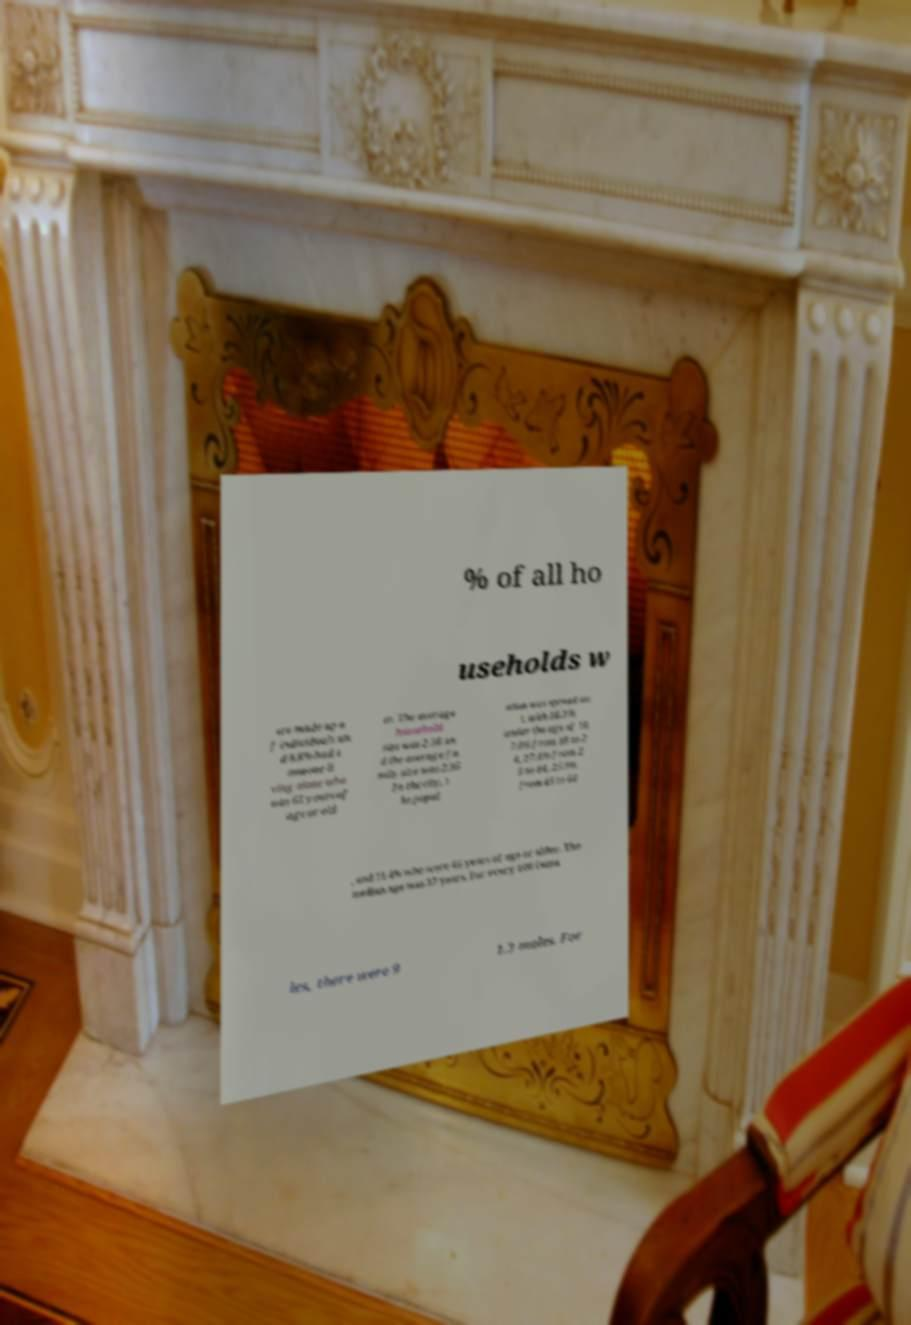Could you assist in decoding the text presented in this image and type it out clearly? % of all ho useholds w ere made up o f individuals an d 8.8% had s omeone li ving alone who was 65 years of age or old er. The average household size was 2.56 an d the average fa mily size was 2.95 .In the city, t he popul ation was spread ou t, with 28.3% under the age of 18, 7.0% from 18 to 2 4, 27.4% from 2 5 to 44, 25.9% from 45 to 64 , and 11.4% who were 65 years of age or older. The median age was 37 years. For every 100 fema les, there were 9 1.3 males. For 